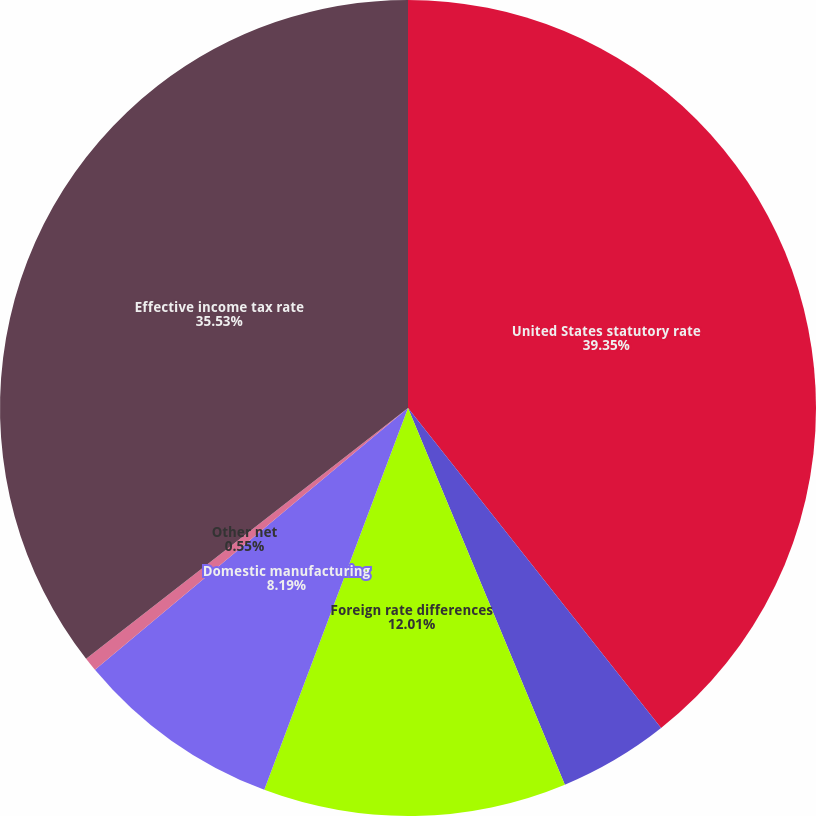Convert chart to OTSL. <chart><loc_0><loc_0><loc_500><loc_500><pie_chart><fcel>United States statutory rate<fcel>State and local income taxes<fcel>Foreign rate differences<fcel>Domestic manufacturing<fcel>Other net<fcel>Effective income tax rate<nl><fcel>39.35%<fcel>4.37%<fcel>12.01%<fcel>8.19%<fcel>0.55%<fcel>35.53%<nl></chart> 